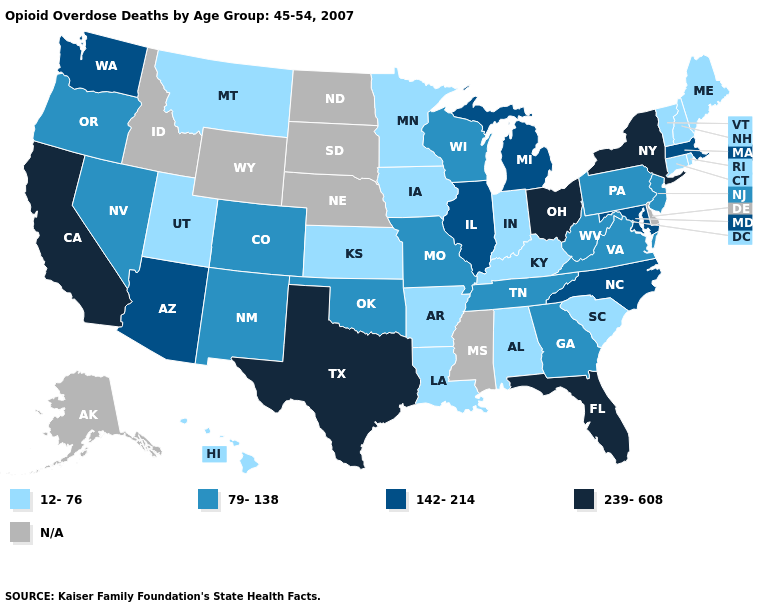What is the value of South Carolina?
Keep it brief. 12-76. Name the states that have a value in the range 142-214?
Answer briefly. Arizona, Illinois, Maryland, Massachusetts, Michigan, North Carolina, Washington. Name the states that have a value in the range 12-76?
Write a very short answer. Alabama, Arkansas, Connecticut, Hawaii, Indiana, Iowa, Kansas, Kentucky, Louisiana, Maine, Minnesota, Montana, New Hampshire, Rhode Island, South Carolina, Utah, Vermont. Does the map have missing data?
Write a very short answer. Yes. Does the map have missing data?
Write a very short answer. Yes. What is the value of Michigan?
Short answer required. 142-214. Is the legend a continuous bar?
Keep it brief. No. Name the states that have a value in the range 142-214?
Be succinct. Arizona, Illinois, Maryland, Massachusetts, Michigan, North Carolina, Washington. Among the states that border Texas , does Louisiana have the lowest value?
Answer briefly. Yes. Name the states that have a value in the range 12-76?
Short answer required. Alabama, Arkansas, Connecticut, Hawaii, Indiana, Iowa, Kansas, Kentucky, Louisiana, Maine, Minnesota, Montana, New Hampshire, Rhode Island, South Carolina, Utah, Vermont. Name the states that have a value in the range 142-214?
Answer briefly. Arizona, Illinois, Maryland, Massachusetts, Michigan, North Carolina, Washington. Does Ohio have the highest value in the MidWest?
Give a very brief answer. Yes. What is the value of New Mexico?
Give a very brief answer. 79-138. Name the states that have a value in the range 239-608?
Short answer required. California, Florida, New York, Ohio, Texas. Does the map have missing data?
Write a very short answer. Yes. 